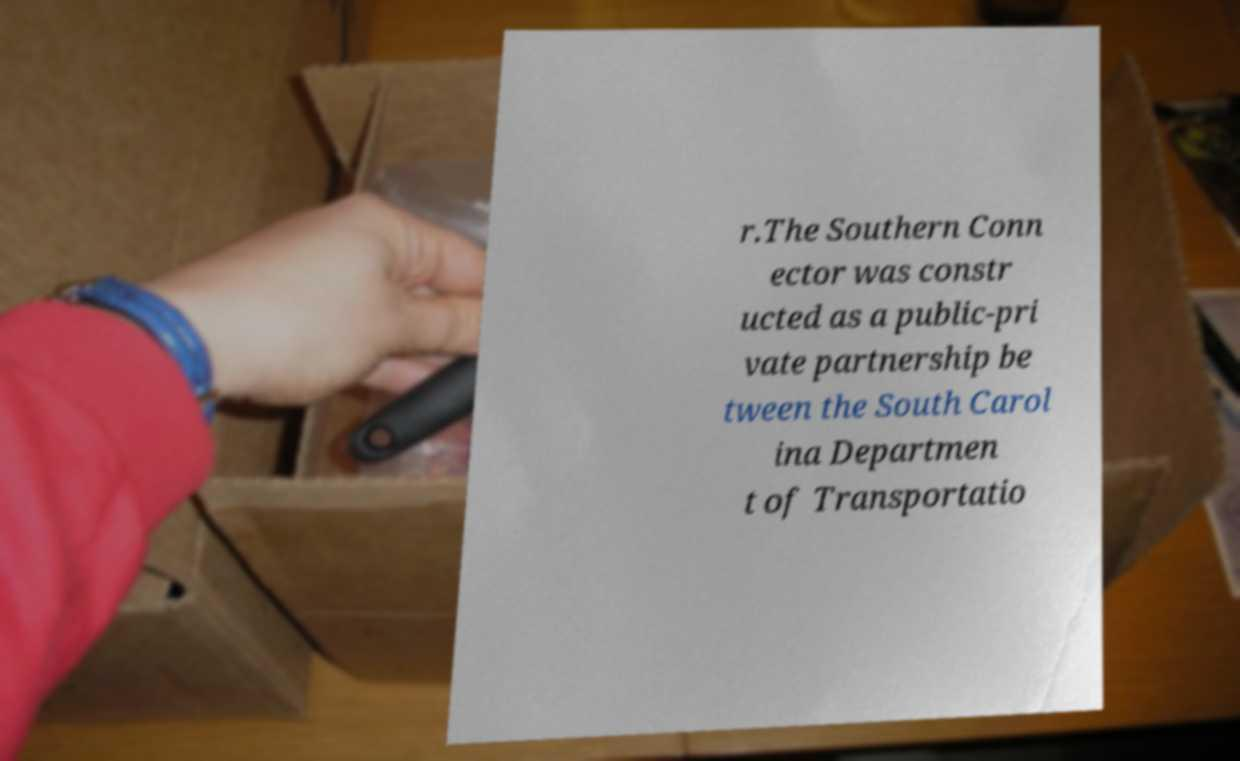What messages or text are displayed in this image? I need them in a readable, typed format. r.The Southern Conn ector was constr ucted as a public-pri vate partnership be tween the South Carol ina Departmen t of Transportatio 